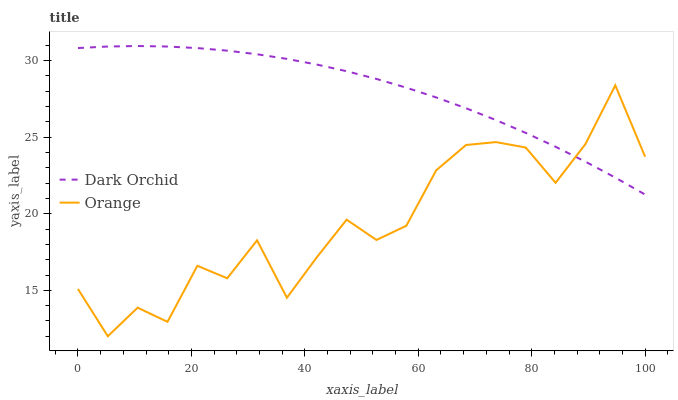Does Orange have the minimum area under the curve?
Answer yes or no. Yes. Does Dark Orchid have the maximum area under the curve?
Answer yes or no. Yes. Does Dark Orchid have the minimum area under the curve?
Answer yes or no. No. Is Dark Orchid the smoothest?
Answer yes or no. Yes. Is Orange the roughest?
Answer yes or no. Yes. Is Dark Orchid the roughest?
Answer yes or no. No. Does Orange have the lowest value?
Answer yes or no. Yes. Does Dark Orchid have the lowest value?
Answer yes or no. No. Does Dark Orchid have the highest value?
Answer yes or no. Yes. Does Dark Orchid intersect Orange?
Answer yes or no. Yes. Is Dark Orchid less than Orange?
Answer yes or no. No. Is Dark Orchid greater than Orange?
Answer yes or no. No. 